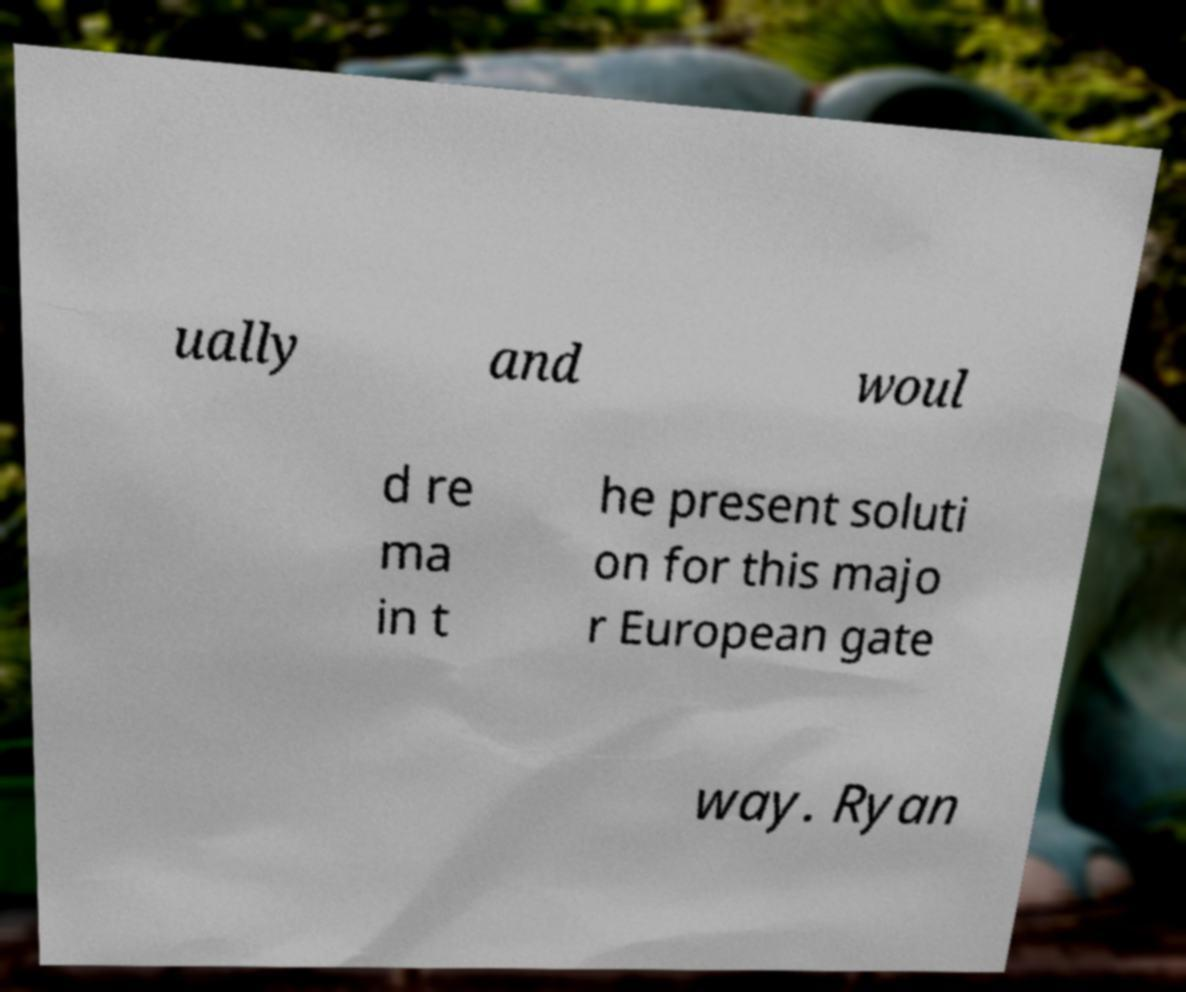What messages or text are displayed in this image? I need them in a readable, typed format. ually and woul d re ma in t he present soluti on for this majo r European gate way. Ryan 